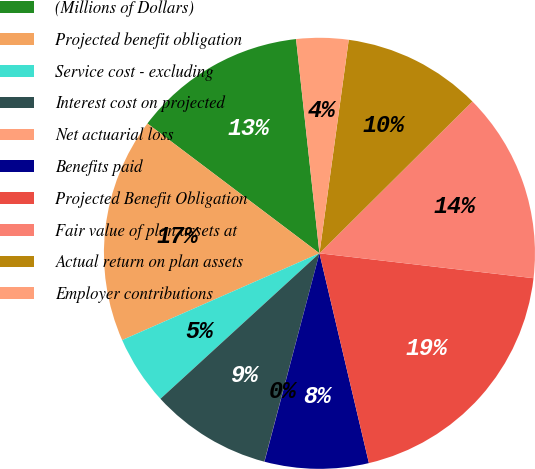Convert chart to OTSL. <chart><loc_0><loc_0><loc_500><loc_500><pie_chart><fcel>(Millions of Dollars)<fcel>Projected benefit obligation<fcel>Service cost - excluding<fcel>Interest cost on projected<fcel>Net actuarial loss<fcel>Benefits paid<fcel>Projected Benefit Obligation<fcel>Fair value of plan assets at<fcel>Actual return on plan assets<fcel>Employer contributions<nl><fcel>12.98%<fcel>16.88%<fcel>5.2%<fcel>9.09%<fcel>0.01%<fcel>7.79%<fcel>19.47%<fcel>14.28%<fcel>10.39%<fcel>3.9%<nl></chart> 